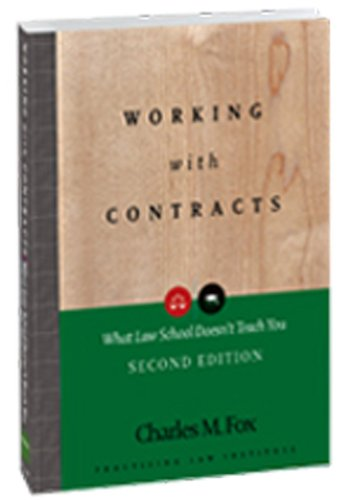What is the title of this book? The title of this book is 'Working With Contracts: What Law School Doesn't Teach You, 2nd Edition  (PLI's Corporate and Securities Law Library)', a comprehensive guide that delves into the intricacies of contract law. 